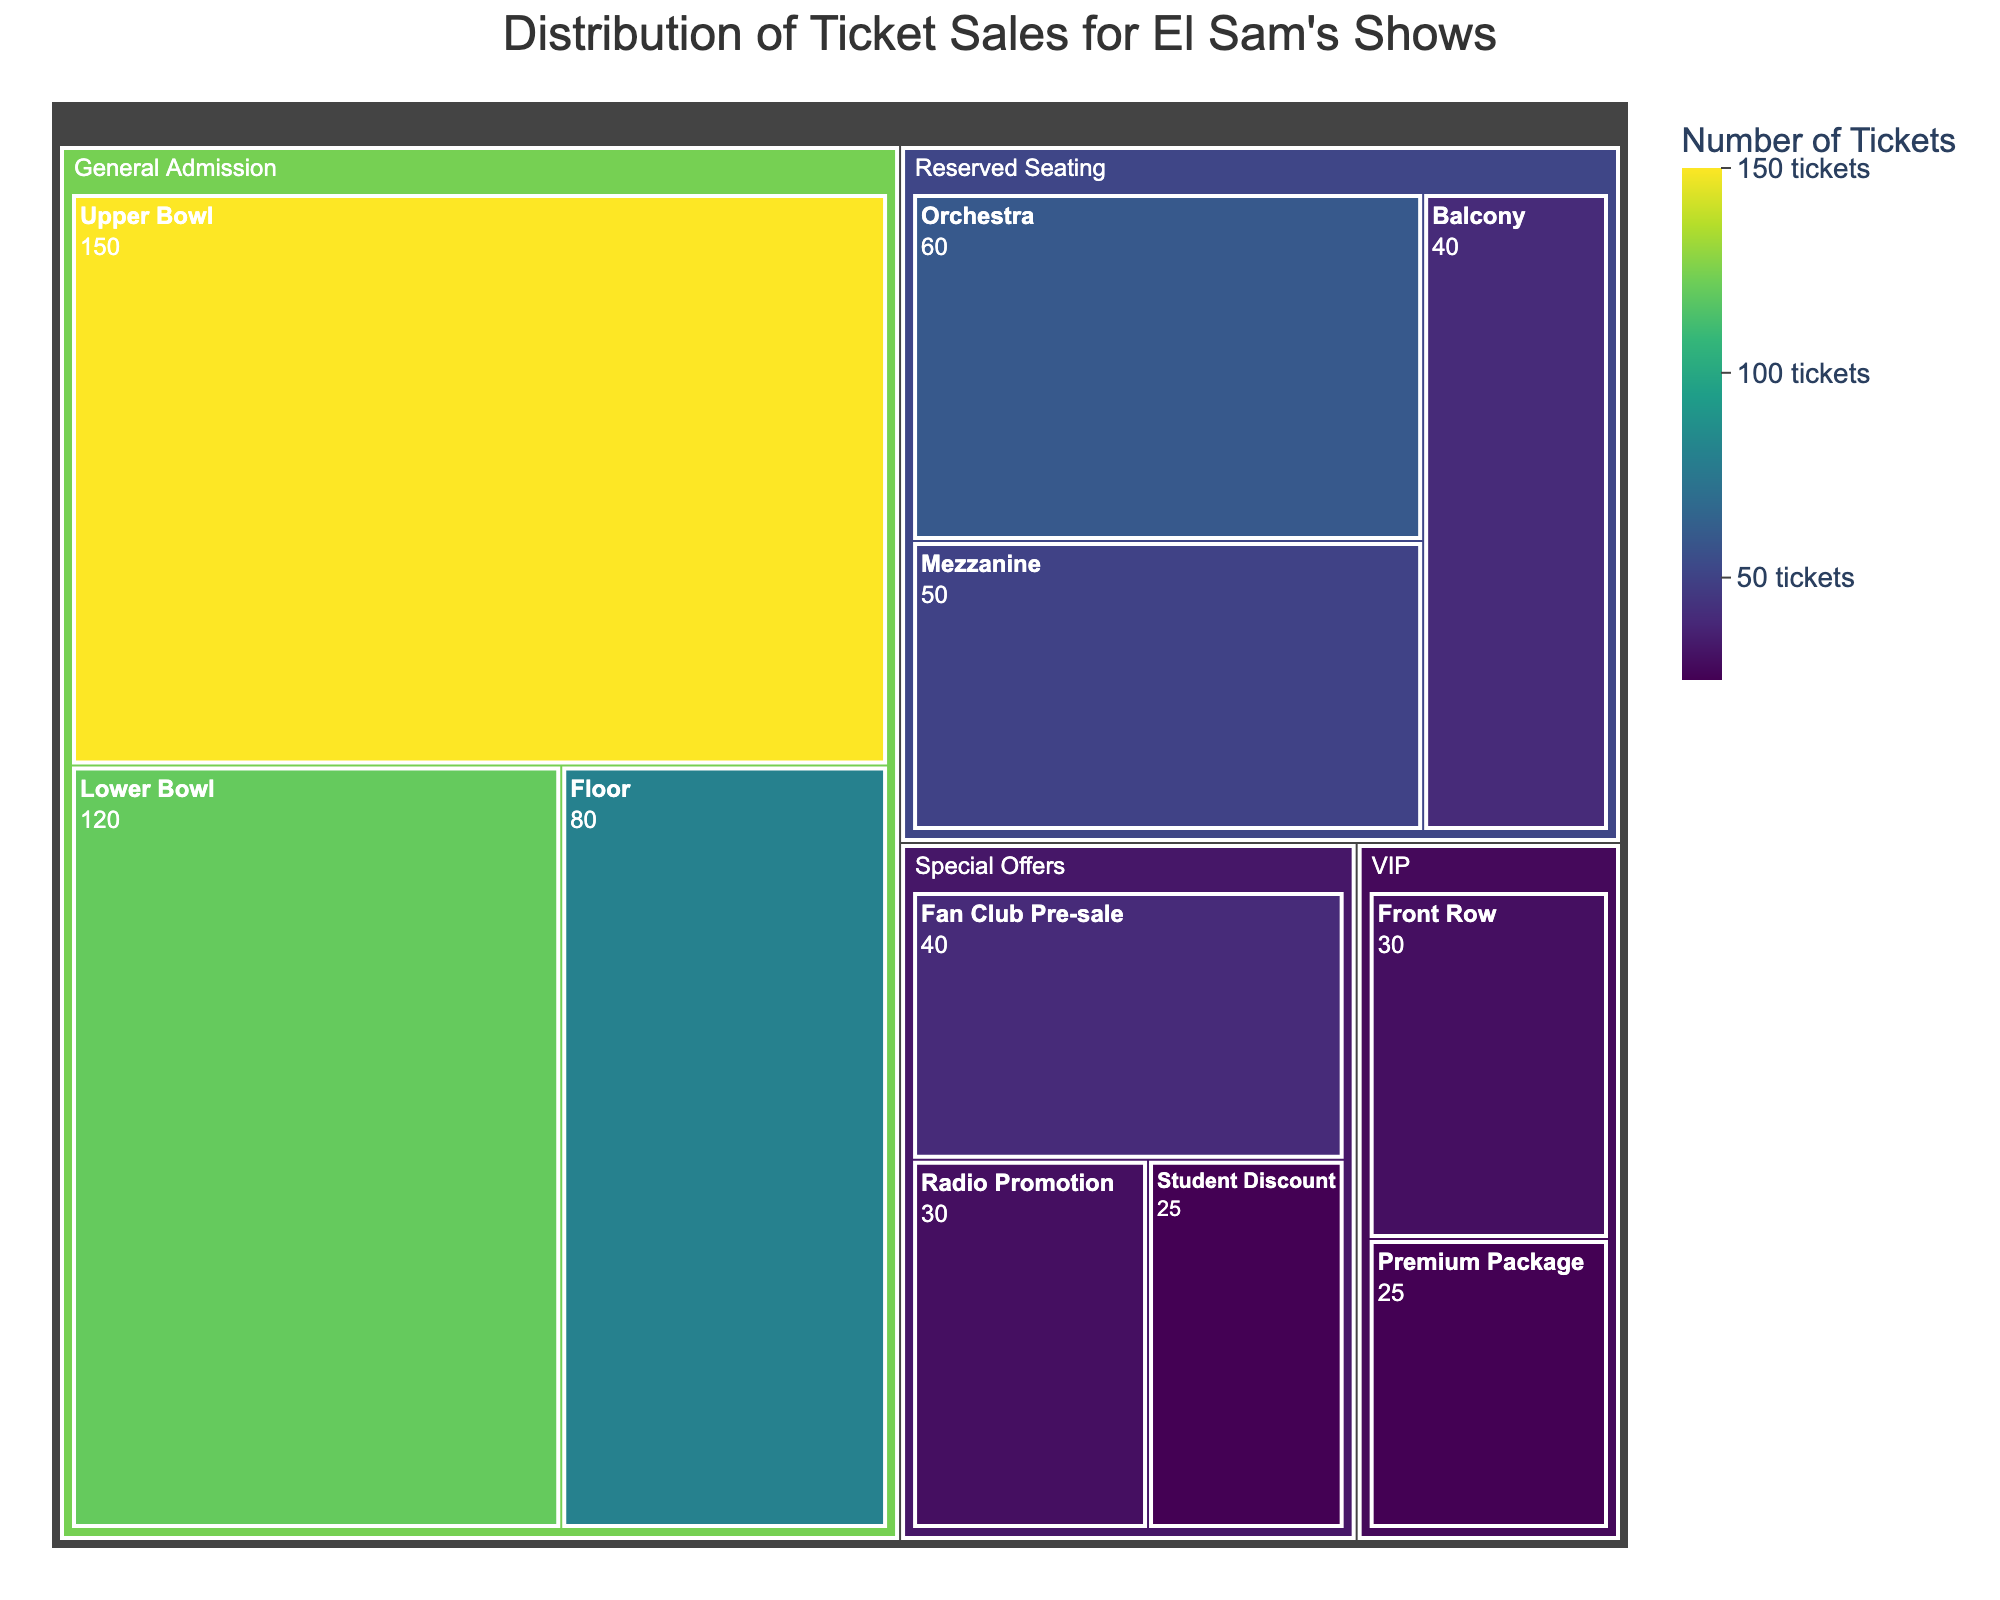What's the title of this treemap? The title of the treemap is located at the top center of the visual, usually in a larger font size for emphasis.
Answer: Distribution of Ticket Sales for El Sam's Shows Which subcategory under General Admission has the highest number of ticket sales? Examine the subcategories listed under General Admission and compare their values. The treemap visually represents this with the size of each tile.
Answer: Upper Bowl How many tickets were sold under Special Offers? Look at each subcategory under the Special Offers category and sum their values (Fan Club Pre-sale: 40, Radio Promotion: 30, Student Discount: 25).
Answer: 95 How does the number of tickets sold in the Mezzanine compare to the Balcony? Identify the values for Mezzanine (50) and Balcony (40) under Reserved Seating and compare them.
Answer: The Mezzanine has 10 more tickets sold than the Balcony How many more tickets were sold in the Lower Bowl compared to the Floor in General Admission? Locate the values for Lower Bowl (120) and Floor (80) under General Admission and find the difference.
Answer: 40 more tickets Which category has the smallest subcategory in terms of ticket sales, and what is its value? Identify the smallest numerical value across all subcategories and note its corresponding category.
Answer: VIP, Premium Package: 25 What is the total number of tickets sold under Reserved Seating? Add up the number of tickets sold in Orchestra (60), Mezzanine (50), and Balcony (40).
Answer: 150 Which has more tickets sold: the Premium Package of VIP or the Student Discount under Special Offers? Compare the values for VIP Premium Package (25) and Special Offers Student Discount (25).
Answer: Both have the same number of tickets sold What is the combined total of ticket sales for both Front Row and Premium Package in the VIP category? Sum the values for Front Row (30) and Premium Package (25) in VIP.
Answer: 55 Is the number of tickets sold for Fan Club Pre-sale higher than the Front Row in the VIP category? Compare the values for Special Offers Fan Club Pre-sale (40) and Front Row in VIP (30).
Answer: Yes, it is higher 